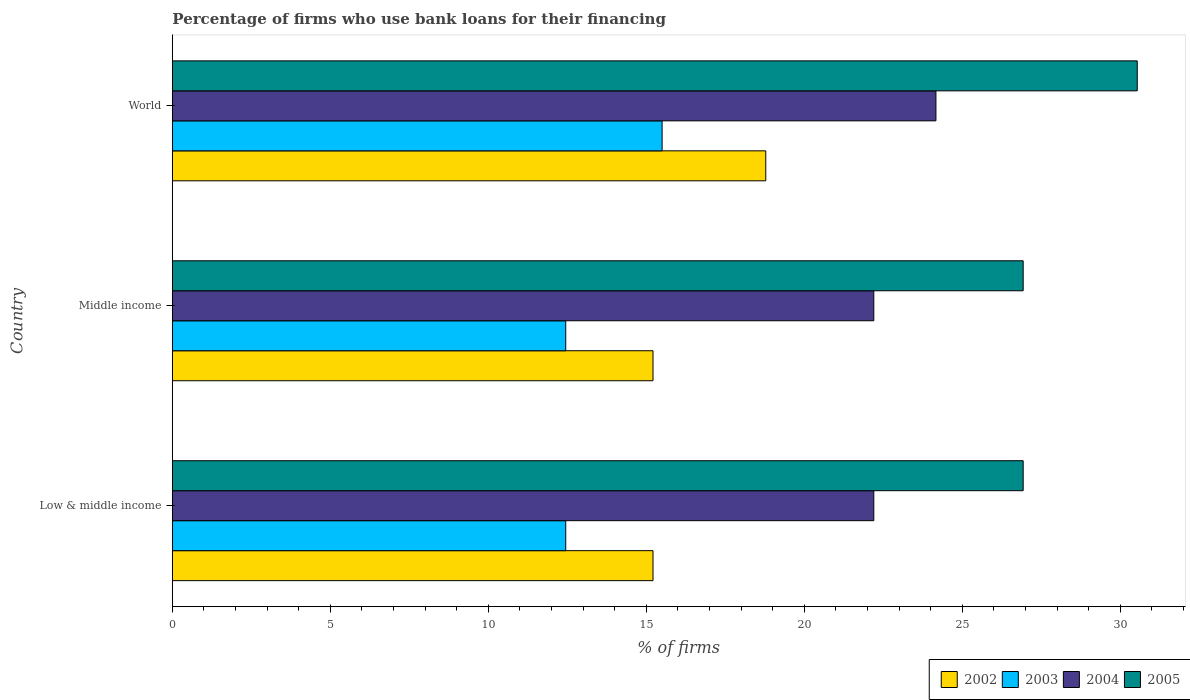How many different coloured bars are there?
Keep it short and to the point. 4. How many groups of bars are there?
Your response must be concise. 3. Are the number of bars on each tick of the Y-axis equal?
Ensure brevity in your answer.  Yes. How many bars are there on the 1st tick from the bottom?
Ensure brevity in your answer.  4. What is the label of the 1st group of bars from the top?
Give a very brief answer. World. In how many cases, is the number of bars for a given country not equal to the number of legend labels?
Give a very brief answer. 0. Across all countries, what is the maximum percentage of firms who use bank loans for their financing in 2004?
Ensure brevity in your answer.  24.17. Across all countries, what is the minimum percentage of firms who use bank loans for their financing in 2002?
Offer a very short reply. 15.21. In which country was the percentage of firms who use bank loans for their financing in 2005 minimum?
Your response must be concise. Low & middle income. What is the total percentage of firms who use bank loans for their financing in 2003 in the graph?
Give a very brief answer. 40.4. What is the difference between the percentage of firms who use bank loans for their financing in 2002 in Low & middle income and that in World?
Ensure brevity in your answer.  -3.57. What is the difference between the percentage of firms who use bank loans for their financing in 2003 in Middle income and the percentage of firms who use bank loans for their financing in 2002 in Low & middle income?
Offer a terse response. -2.76. What is the average percentage of firms who use bank loans for their financing in 2003 per country?
Give a very brief answer. 13.47. What is the difference between the percentage of firms who use bank loans for their financing in 2004 and percentage of firms who use bank loans for their financing in 2002 in Middle income?
Ensure brevity in your answer.  6.99. What is the ratio of the percentage of firms who use bank loans for their financing in 2005 in Middle income to that in World?
Make the answer very short. 0.88. What is the difference between the highest and the second highest percentage of firms who use bank loans for their financing in 2004?
Make the answer very short. 1.97. What is the difference between the highest and the lowest percentage of firms who use bank loans for their financing in 2002?
Make the answer very short. 3.57. Is the sum of the percentage of firms who use bank loans for their financing in 2004 in Low & middle income and World greater than the maximum percentage of firms who use bank loans for their financing in 2003 across all countries?
Make the answer very short. Yes. Is it the case that in every country, the sum of the percentage of firms who use bank loans for their financing in 2005 and percentage of firms who use bank loans for their financing in 2002 is greater than the sum of percentage of firms who use bank loans for their financing in 2004 and percentage of firms who use bank loans for their financing in 2003?
Make the answer very short. Yes. Is it the case that in every country, the sum of the percentage of firms who use bank loans for their financing in 2004 and percentage of firms who use bank loans for their financing in 2003 is greater than the percentage of firms who use bank loans for their financing in 2005?
Make the answer very short. Yes. How many bars are there?
Your response must be concise. 12. Are all the bars in the graph horizontal?
Offer a terse response. Yes. What is the difference between two consecutive major ticks on the X-axis?
Make the answer very short. 5. Are the values on the major ticks of X-axis written in scientific E-notation?
Offer a very short reply. No. Does the graph contain any zero values?
Your response must be concise. No. Does the graph contain grids?
Make the answer very short. No. How are the legend labels stacked?
Offer a very short reply. Horizontal. What is the title of the graph?
Provide a short and direct response. Percentage of firms who use bank loans for their financing. Does "1998" appear as one of the legend labels in the graph?
Offer a very short reply. No. What is the label or title of the X-axis?
Your answer should be compact. % of firms. What is the label or title of the Y-axis?
Provide a short and direct response. Country. What is the % of firms of 2002 in Low & middle income?
Provide a succinct answer. 15.21. What is the % of firms in 2003 in Low & middle income?
Your answer should be very brief. 12.45. What is the % of firms of 2004 in Low & middle income?
Provide a succinct answer. 22.2. What is the % of firms in 2005 in Low & middle income?
Offer a very short reply. 26.93. What is the % of firms of 2002 in Middle income?
Keep it short and to the point. 15.21. What is the % of firms of 2003 in Middle income?
Keep it short and to the point. 12.45. What is the % of firms of 2005 in Middle income?
Your response must be concise. 26.93. What is the % of firms in 2002 in World?
Offer a terse response. 18.78. What is the % of firms of 2004 in World?
Offer a terse response. 24.17. What is the % of firms in 2005 in World?
Your answer should be very brief. 30.54. Across all countries, what is the maximum % of firms in 2002?
Offer a terse response. 18.78. Across all countries, what is the maximum % of firms in 2003?
Your response must be concise. 15.5. Across all countries, what is the maximum % of firms of 2004?
Your answer should be compact. 24.17. Across all countries, what is the maximum % of firms in 2005?
Your answer should be very brief. 30.54. Across all countries, what is the minimum % of firms in 2002?
Your response must be concise. 15.21. Across all countries, what is the minimum % of firms of 2003?
Give a very brief answer. 12.45. Across all countries, what is the minimum % of firms in 2004?
Ensure brevity in your answer.  22.2. Across all countries, what is the minimum % of firms of 2005?
Keep it short and to the point. 26.93. What is the total % of firms of 2002 in the graph?
Give a very brief answer. 49.21. What is the total % of firms of 2003 in the graph?
Give a very brief answer. 40.4. What is the total % of firms of 2004 in the graph?
Provide a short and direct response. 68.57. What is the total % of firms of 2005 in the graph?
Offer a very short reply. 84.39. What is the difference between the % of firms of 2005 in Low & middle income and that in Middle income?
Provide a succinct answer. 0. What is the difference between the % of firms in 2002 in Low & middle income and that in World?
Offer a terse response. -3.57. What is the difference between the % of firms of 2003 in Low & middle income and that in World?
Ensure brevity in your answer.  -3.05. What is the difference between the % of firms of 2004 in Low & middle income and that in World?
Your answer should be compact. -1.97. What is the difference between the % of firms in 2005 in Low & middle income and that in World?
Your answer should be very brief. -3.61. What is the difference between the % of firms in 2002 in Middle income and that in World?
Provide a succinct answer. -3.57. What is the difference between the % of firms in 2003 in Middle income and that in World?
Ensure brevity in your answer.  -3.05. What is the difference between the % of firms of 2004 in Middle income and that in World?
Offer a very short reply. -1.97. What is the difference between the % of firms of 2005 in Middle income and that in World?
Your answer should be compact. -3.61. What is the difference between the % of firms of 2002 in Low & middle income and the % of firms of 2003 in Middle income?
Your answer should be very brief. 2.76. What is the difference between the % of firms of 2002 in Low & middle income and the % of firms of 2004 in Middle income?
Offer a terse response. -6.99. What is the difference between the % of firms of 2002 in Low & middle income and the % of firms of 2005 in Middle income?
Ensure brevity in your answer.  -11.72. What is the difference between the % of firms of 2003 in Low & middle income and the % of firms of 2004 in Middle income?
Provide a short and direct response. -9.75. What is the difference between the % of firms of 2003 in Low & middle income and the % of firms of 2005 in Middle income?
Offer a terse response. -14.48. What is the difference between the % of firms in 2004 in Low & middle income and the % of firms in 2005 in Middle income?
Offer a terse response. -4.73. What is the difference between the % of firms in 2002 in Low & middle income and the % of firms in 2003 in World?
Ensure brevity in your answer.  -0.29. What is the difference between the % of firms of 2002 in Low & middle income and the % of firms of 2004 in World?
Give a very brief answer. -8.95. What is the difference between the % of firms of 2002 in Low & middle income and the % of firms of 2005 in World?
Make the answer very short. -15.33. What is the difference between the % of firms in 2003 in Low & middle income and the % of firms in 2004 in World?
Provide a short and direct response. -11.72. What is the difference between the % of firms of 2003 in Low & middle income and the % of firms of 2005 in World?
Your response must be concise. -18.09. What is the difference between the % of firms in 2004 in Low & middle income and the % of firms in 2005 in World?
Keep it short and to the point. -8.34. What is the difference between the % of firms in 2002 in Middle income and the % of firms in 2003 in World?
Your response must be concise. -0.29. What is the difference between the % of firms in 2002 in Middle income and the % of firms in 2004 in World?
Offer a very short reply. -8.95. What is the difference between the % of firms in 2002 in Middle income and the % of firms in 2005 in World?
Your answer should be compact. -15.33. What is the difference between the % of firms in 2003 in Middle income and the % of firms in 2004 in World?
Provide a succinct answer. -11.72. What is the difference between the % of firms of 2003 in Middle income and the % of firms of 2005 in World?
Give a very brief answer. -18.09. What is the difference between the % of firms in 2004 in Middle income and the % of firms in 2005 in World?
Ensure brevity in your answer.  -8.34. What is the average % of firms of 2002 per country?
Provide a succinct answer. 16.4. What is the average % of firms in 2003 per country?
Give a very brief answer. 13.47. What is the average % of firms in 2004 per country?
Make the answer very short. 22.86. What is the average % of firms in 2005 per country?
Your answer should be compact. 28.13. What is the difference between the % of firms in 2002 and % of firms in 2003 in Low & middle income?
Keep it short and to the point. 2.76. What is the difference between the % of firms in 2002 and % of firms in 2004 in Low & middle income?
Ensure brevity in your answer.  -6.99. What is the difference between the % of firms of 2002 and % of firms of 2005 in Low & middle income?
Provide a short and direct response. -11.72. What is the difference between the % of firms of 2003 and % of firms of 2004 in Low & middle income?
Offer a terse response. -9.75. What is the difference between the % of firms of 2003 and % of firms of 2005 in Low & middle income?
Your answer should be compact. -14.48. What is the difference between the % of firms in 2004 and % of firms in 2005 in Low & middle income?
Your answer should be very brief. -4.73. What is the difference between the % of firms in 2002 and % of firms in 2003 in Middle income?
Provide a short and direct response. 2.76. What is the difference between the % of firms of 2002 and % of firms of 2004 in Middle income?
Keep it short and to the point. -6.99. What is the difference between the % of firms in 2002 and % of firms in 2005 in Middle income?
Keep it short and to the point. -11.72. What is the difference between the % of firms of 2003 and % of firms of 2004 in Middle income?
Offer a very short reply. -9.75. What is the difference between the % of firms in 2003 and % of firms in 2005 in Middle income?
Give a very brief answer. -14.48. What is the difference between the % of firms in 2004 and % of firms in 2005 in Middle income?
Your answer should be compact. -4.73. What is the difference between the % of firms in 2002 and % of firms in 2003 in World?
Your answer should be compact. 3.28. What is the difference between the % of firms of 2002 and % of firms of 2004 in World?
Ensure brevity in your answer.  -5.39. What is the difference between the % of firms of 2002 and % of firms of 2005 in World?
Make the answer very short. -11.76. What is the difference between the % of firms in 2003 and % of firms in 2004 in World?
Make the answer very short. -8.67. What is the difference between the % of firms in 2003 and % of firms in 2005 in World?
Keep it short and to the point. -15.04. What is the difference between the % of firms of 2004 and % of firms of 2005 in World?
Offer a very short reply. -6.37. What is the ratio of the % of firms of 2003 in Low & middle income to that in Middle income?
Offer a terse response. 1. What is the ratio of the % of firms of 2002 in Low & middle income to that in World?
Provide a short and direct response. 0.81. What is the ratio of the % of firms of 2003 in Low & middle income to that in World?
Your answer should be compact. 0.8. What is the ratio of the % of firms of 2004 in Low & middle income to that in World?
Offer a very short reply. 0.92. What is the ratio of the % of firms of 2005 in Low & middle income to that in World?
Make the answer very short. 0.88. What is the ratio of the % of firms in 2002 in Middle income to that in World?
Your answer should be very brief. 0.81. What is the ratio of the % of firms of 2003 in Middle income to that in World?
Your answer should be compact. 0.8. What is the ratio of the % of firms in 2004 in Middle income to that in World?
Your answer should be very brief. 0.92. What is the ratio of the % of firms in 2005 in Middle income to that in World?
Offer a very short reply. 0.88. What is the difference between the highest and the second highest % of firms in 2002?
Provide a short and direct response. 3.57. What is the difference between the highest and the second highest % of firms of 2003?
Your response must be concise. 3.05. What is the difference between the highest and the second highest % of firms in 2004?
Your response must be concise. 1.97. What is the difference between the highest and the second highest % of firms in 2005?
Provide a succinct answer. 3.61. What is the difference between the highest and the lowest % of firms in 2002?
Keep it short and to the point. 3.57. What is the difference between the highest and the lowest % of firms in 2003?
Ensure brevity in your answer.  3.05. What is the difference between the highest and the lowest % of firms in 2004?
Your answer should be compact. 1.97. What is the difference between the highest and the lowest % of firms of 2005?
Make the answer very short. 3.61. 